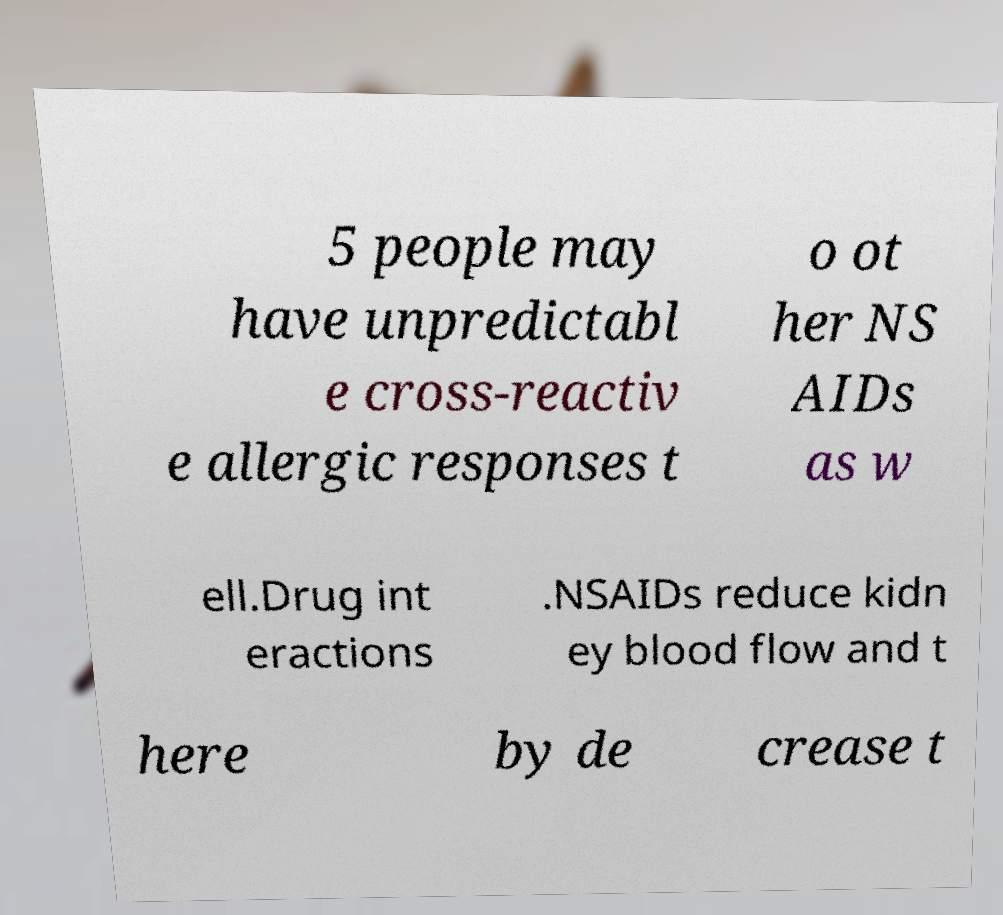Can you accurately transcribe the text from the provided image for me? 5 people may have unpredictabl e cross-reactiv e allergic responses t o ot her NS AIDs as w ell.Drug int eractions .NSAIDs reduce kidn ey blood flow and t here by de crease t 